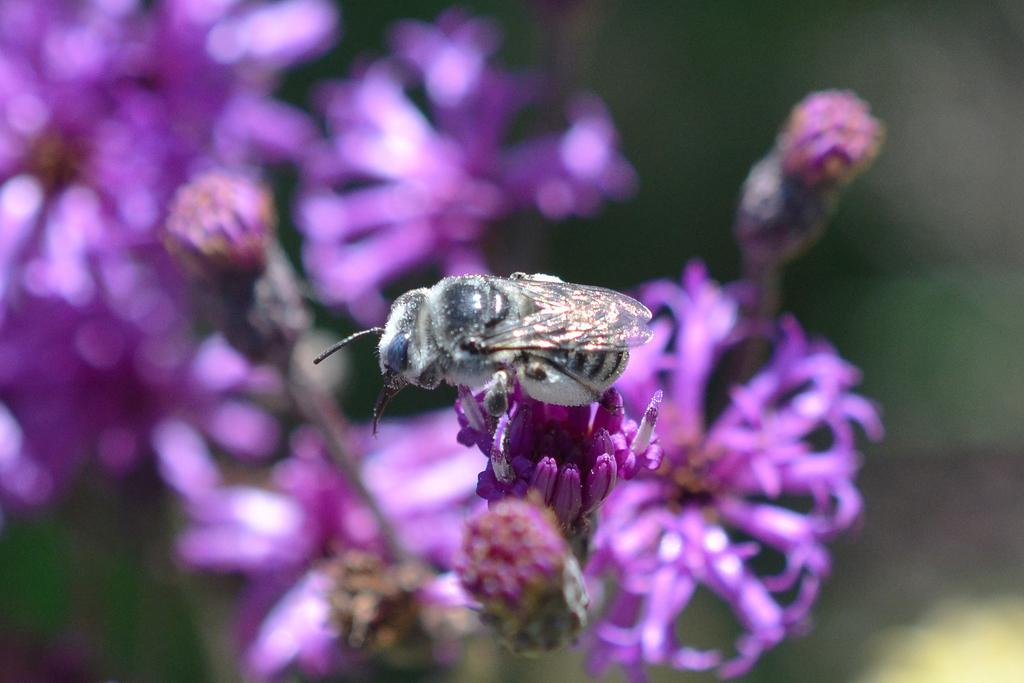What is the main subject of the image? There is an insect in the image. Where is the insect located? The insect is on a purple flower. Can you describe the background of the image? The background of the image is blurred. What else can be seen in the background besides the blurred area? There are more purple flowers visible in the background. What type of polish is the insect using on the flower? There is no indication in the image that the insect is using any polish on the flower. How much payment is the insect receiving for sitting on the flower? There is no indication in the image that the insects receive payment for sitting on flowers. 